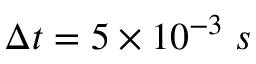Convert formula to latex. <formula><loc_0><loc_0><loc_500><loc_500>\Delta t = 5 \times 1 0 ^ { - 3 } \, s</formula> 